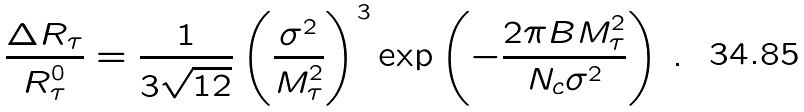<formula> <loc_0><loc_0><loc_500><loc_500>\frac { \Delta R _ { \tau } } { R _ { \tau } ^ { 0 } } = \frac { 1 } { 3 \sqrt { 1 2 } } \left ( \frac { \sigma ^ { 2 } } { M _ { \tau } ^ { 2 } } \right ) ^ { 3 } { \exp } \left ( - \frac { 2 \pi B M ^ { 2 } _ { \tau } } { N _ { c } \sigma ^ { 2 } } \right ) \, .</formula> 